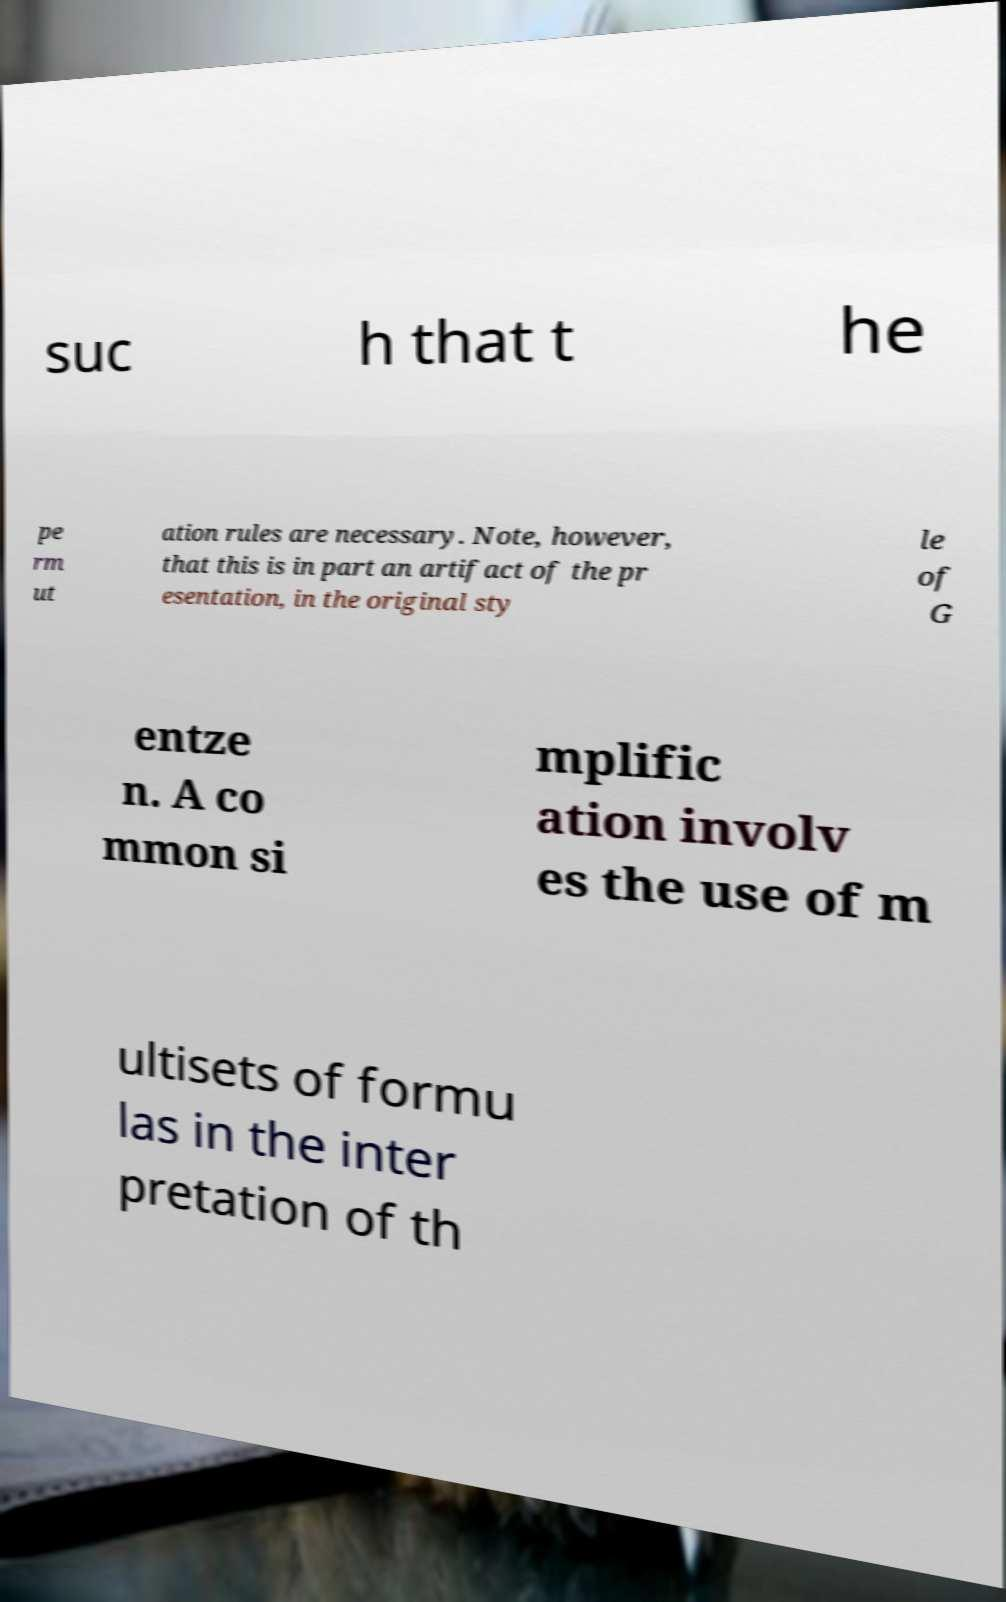There's text embedded in this image that I need extracted. Can you transcribe it verbatim? suc h that t he pe rm ut ation rules are necessary. Note, however, that this is in part an artifact of the pr esentation, in the original sty le of G entze n. A co mmon si mplific ation involv es the use of m ultisets of formu las in the inter pretation of th 